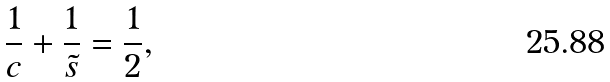Convert formula to latex. <formula><loc_0><loc_0><loc_500><loc_500>\frac { 1 } { c } + \frac { 1 } { \tilde { s } } = \frac { 1 } { 2 } ,</formula> 